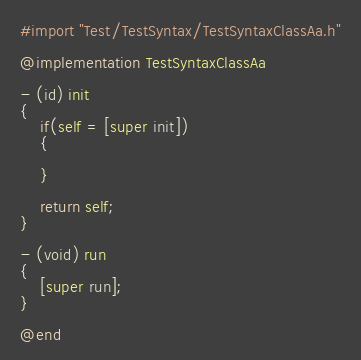<code> <loc_0><loc_0><loc_500><loc_500><_ObjectiveC_>#import "Test/TestSyntax/TestSyntaxClassAa.h"

@implementation TestSyntaxClassAa

- (id) init
{
    if(self = [super init])
    {
        
    }
    
    return self;
}

- (void) run
{
    [super run];
}

@end</code> 